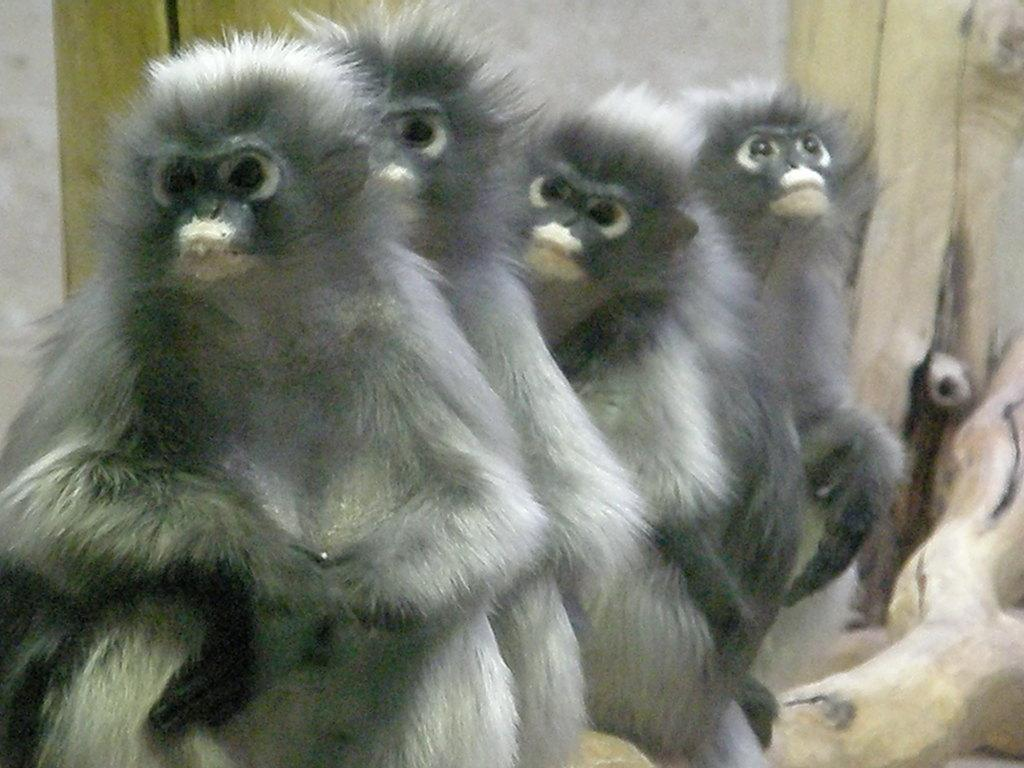What animals are present in the image? There are monkeys in the picture. Where are the monkeys located in the image? The monkeys are sitting on the stem of something, possibly a tree or a plant. What type of apparatus is the monkey using to make an argument in the image? There is no apparatus or argument present in the image; it features monkeys sitting on a stem. 